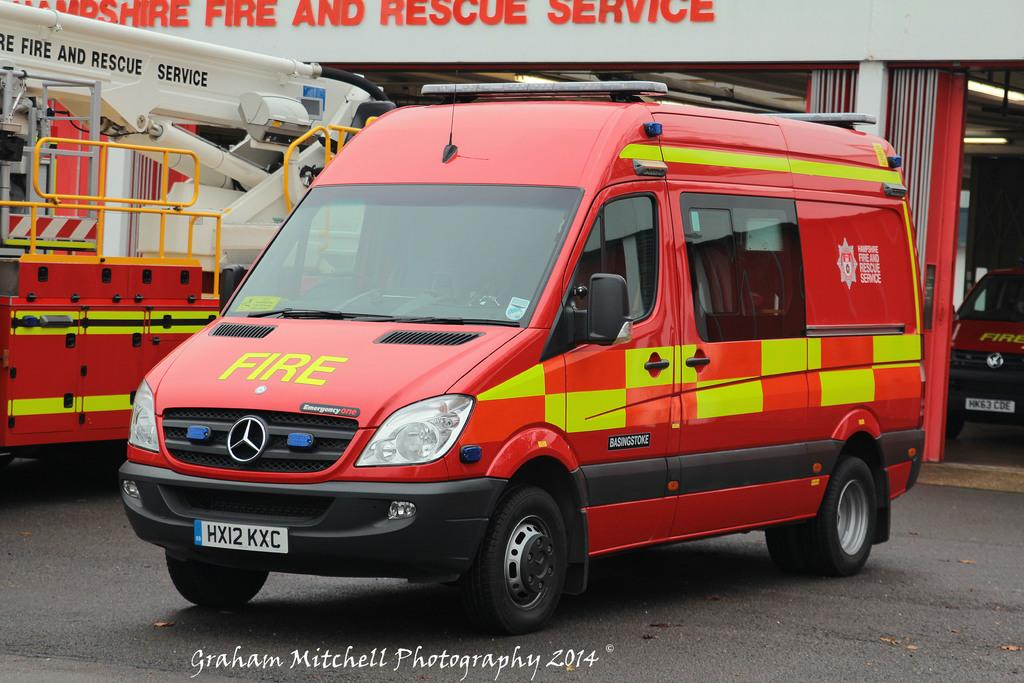<image>
Relay a brief, clear account of the picture shown. A red van with yellow checkers says Fire. 